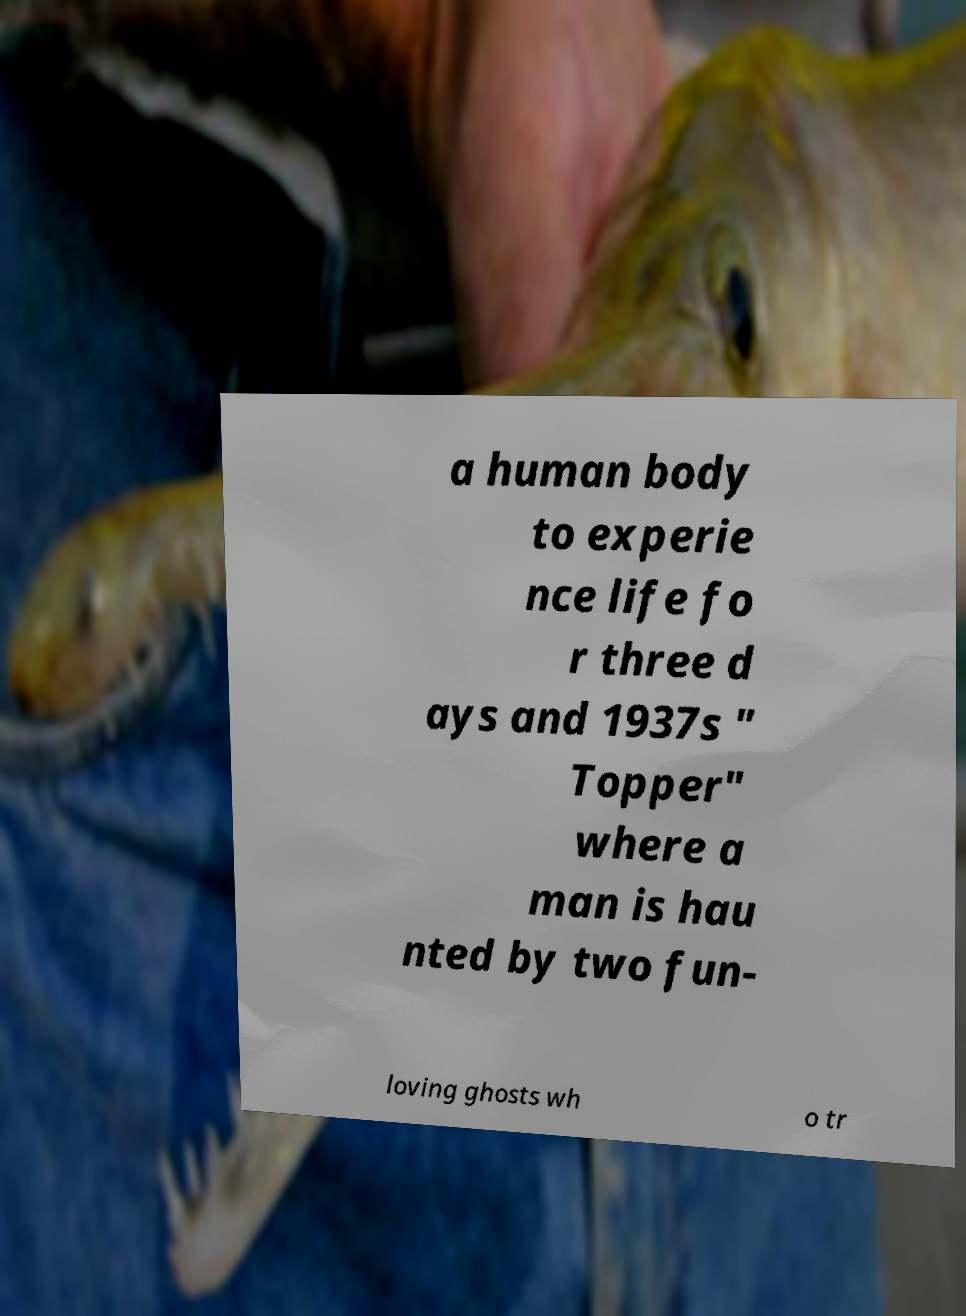Could you extract and type out the text from this image? a human body to experie nce life fo r three d ays and 1937s " Topper" where a man is hau nted by two fun- loving ghosts wh o tr 